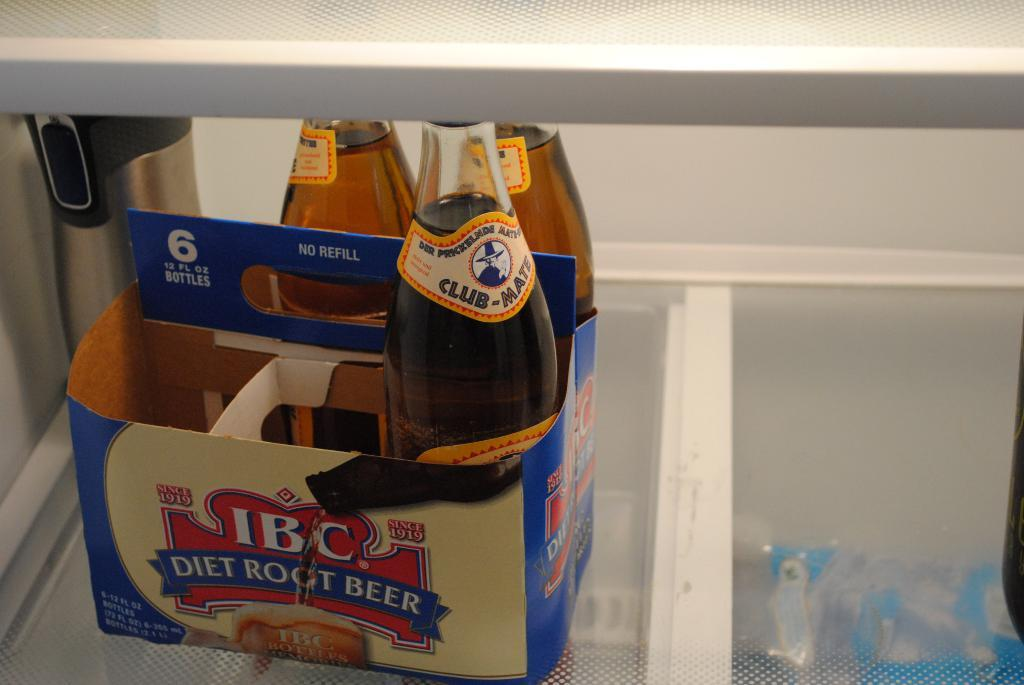<image>
Present a compact description of the photo's key features. A box with three bottles of IBC diet root beer. 